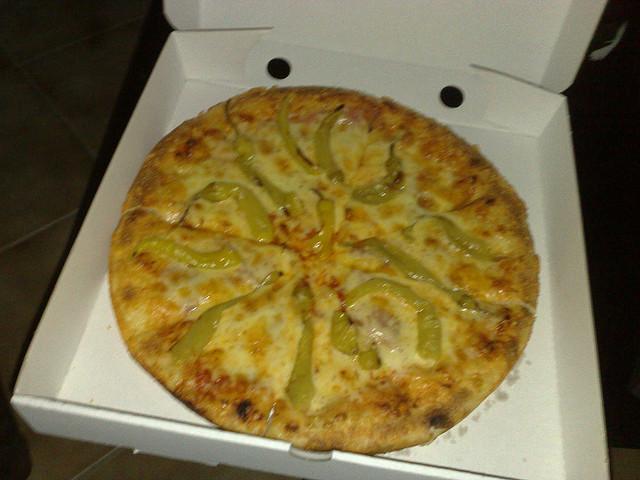How many pizzas are in the photo?
Give a very brief answer. 1. How many people are in this picture?
Give a very brief answer. 0. 